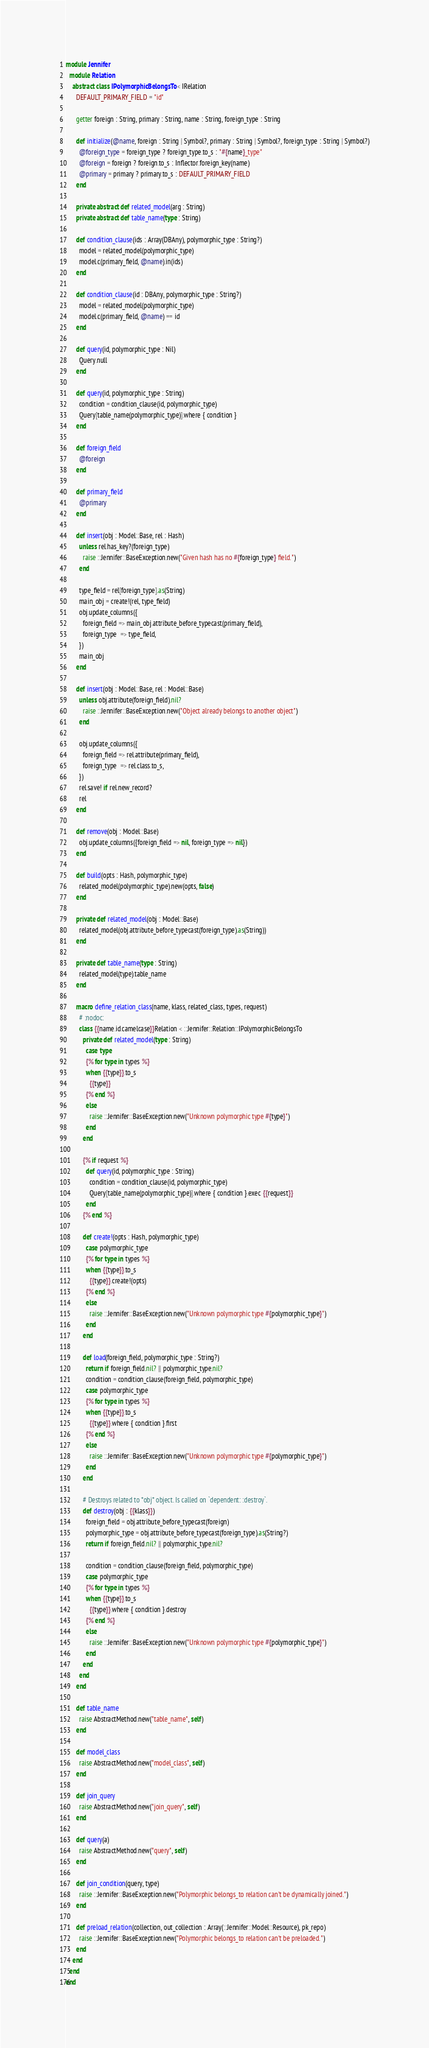Convert code to text. <code><loc_0><loc_0><loc_500><loc_500><_Crystal_>module Jennifer
  module Relation
    abstract class IPolymorphicBelongsTo < IRelation
      DEFAULT_PRIMARY_FIELD = "id"

      getter foreign : String, primary : String, name : String, foreign_type : String

      def initialize(@name, foreign : String | Symbol?, primary : String | Symbol?, foreign_type : String | Symbol?)
        @foreign_type = foreign_type ? foreign_type.to_s : "#{name}_type"
        @foreign = foreign ? foreign.to_s : Inflector.foreign_key(name)
        @primary = primary ? primary.to_s : DEFAULT_PRIMARY_FIELD
      end

      private abstract def related_model(arg : String)
      private abstract def table_name(type : String)

      def condition_clause(ids : Array(DBAny), polymorphic_type : String?)
        model = related_model(polymorphic_type)
        model.c(primary_field, @name).in(ids)
      end

      def condition_clause(id : DBAny, polymorphic_type : String?)
        model = related_model(polymorphic_type)
        model.c(primary_field, @name) == id
      end

      def query(id, polymorphic_type : Nil)
        Query.null
      end

      def query(id, polymorphic_type : String)
        condition = condition_clause(id, polymorphic_type)
        Query[table_name(polymorphic_type)].where { condition }
      end

      def foreign_field
        @foreign
      end

      def primary_field
        @primary
      end

      def insert(obj : Model::Base, rel : Hash)
        unless rel.has_key?(foreign_type)
          raise ::Jennifer::BaseException.new("Given hash has no #{foreign_type} field.")
        end

        type_field = rel[foreign_type].as(String)
        main_obj = create!(rel, type_field)
        obj.update_columns({
          foreign_field => main_obj.attribute_before_typecast(primary_field),
          foreign_type  => type_field,
        })
        main_obj
      end

      def insert(obj : Model::Base, rel : Model::Base)
        unless obj.attribute(foreign_field).nil?
          raise ::Jennifer::BaseException.new("Object already belongs to another object")
        end

        obj.update_columns({
          foreign_field => rel.attribute(primary_field),
          foreign_type  => rel.class.to_s,
        })
        rel.save! if rel.new_record?
        rel
      end

      def remove(obj : Model::Base)
        obj.update_columns({foreign_field => nil, foreign_type => nil})
      end

      def build(opts : Hash, polymorphic_type)
        related_model(polymorphic_type).new(opts, false)
      end

      private def related_model(obj : Model::Base)
        related_model(obj.attribute_before_typecast(foreign_type).as(String))
      end

      private def table_name(type : String)
        related_model(type).table_name
      end

      macro define_relation_class(name, klass, related_class, types, request)
        # :nodoc:
        class {{name.id.camelcase}}Relation < ::Jennifer::Relation::IPolymorphicBelongsTo
          private def related_model(type : String)
            case type
            {% for type in types %}
            when {{type}}.to_s
              {{type}}
            {% end %}
            else
              raise ::Jennifer::BaseException.new("Unknown polymorphic type #{type}")
            end
          end

          {% if request %}
            def query(id, polymorphic_type : String)
              condition = condition_clause(id, polymorphic_type)
              Query[table_name(polymorphic_type)].where { condition }.exec {{request}}
            end
          {% end %}

          def create!(opts : Hash, polymorphic_type)
            case polymorphic_type
            {% for type in types %}
            when {{type}}.to_s
              {{type}}.create!(opts)
            {% end %}
            else
              raise ::Jennifer::BaseException.new("Unknown polymorphic type #{polymorphic_type}")
            end
          end

          def load(foreign_field, polymorphic_type : String?)
            return if foreign_field.nil? || polymorphic_type.nil?
            condition = condition_clause(foreign_field, polymorphic_type)
            case polymorphic_type
            {% for type in types %}
            when {{type}}.to_s
              {{type}}.where { condition }.first
            {% end %}
            else
              raise ::Jennifer::BaseException.new("Unknown polymorphic type #{polymorphic_type}")
            end
          end

          # Destroys related to *obj* object. Is called on `dependent: :destroy`.
          def destroy(obj : {{klass}})
            foreign_field = obj.attribute_before_typecast(foreign)
            polymorphic_type = obj.attribute_before_typecast(foreign_type).as(String?)
            return if foreign_field.nil? || polymorphic_type.nil?

            condition = condition_clause(foreign_field, polymorphic_type)
            case polymorphic_type
            {% for type in types %}
            when {{type}}.to_s
              {{type}}.where { condition }.destroy
            {% end %}
            else
              raise ::Jennifer::BaseException.new("Unknown polymorphic type #{polymorphic_type}")
            end
          end
        end
      end

      def table_name
        raise AbstractMethod.new("table_name", self)
      end

      def model_class
        raise AbstractMethod.new("model_class", self)
      end

      def join_query
        raise AbstractMethod.new("join_query", self)
      end

      def query(a)
        raise AbstractMethod.new("query", self)
      end

      def join_condition(query, type)
        raise ::Jennifer::BaseException.new("Polymorphic belongs_to relation can't be dynamically joined.")
      end

      def preload_relation(collection, out_collection : Array(::Jennifer::Model::Resource), pk_repo)
        raise ::Jennifer::BaseException.new("Polymorphic belongs_to relation can't be preloaded.")
      end
    end
  end
end
</code> 